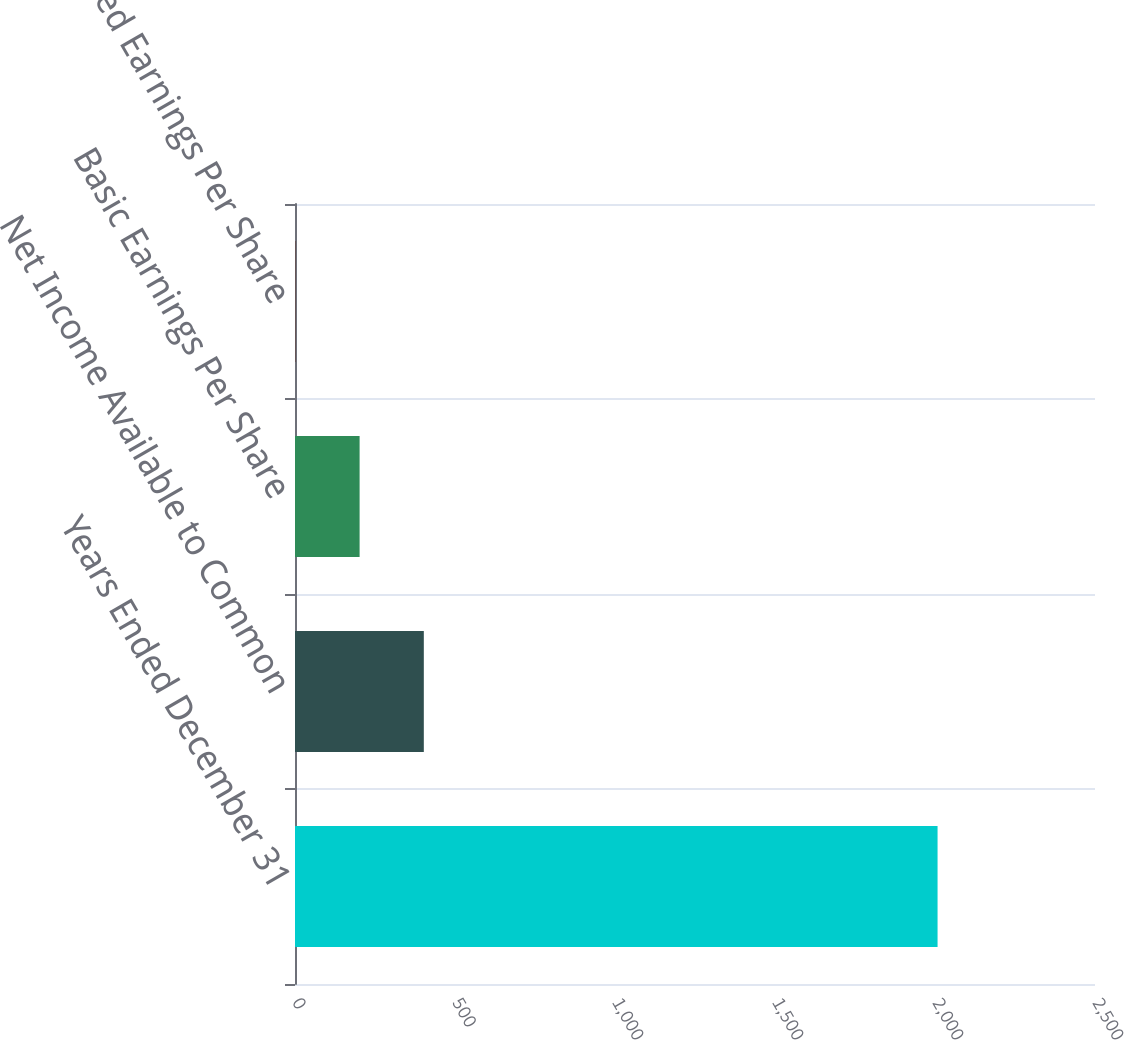Convert chart to OTSL. <chart><loc_0><loc_0><loc_500><loc_500><bar_chart><fcel>Years Ended December 31<fcel>Net Income Available to Common<fcel>Basic Earnings Per Share<fcel>Diluted Earnings Per Share<nl><fcel>2008<fcel>402.56<fcel>201.88<fcel>1.2<nl></chart> 